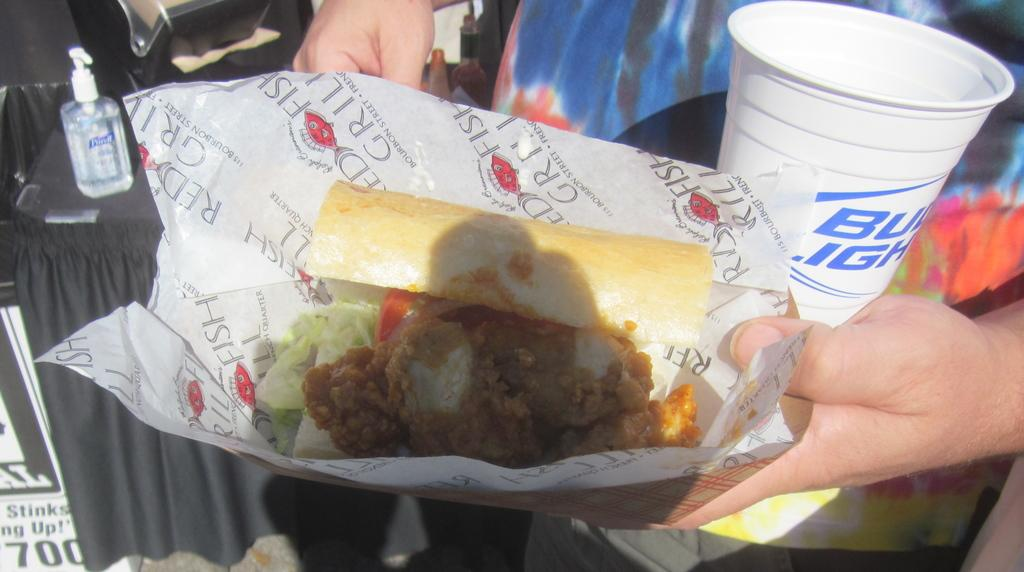What is the person in the image doing? The person is standing and holding a cup and cover with food. What else can be seen on the table in the image? There is a bottle on the table in the image. What is the board used for in the image? The purpose of the board in the image is not specified, but it is present. Can you describe the objects visible in the image? Yes, there are objects visible in the image, including the person, the cup and cover with food, the bottle, and the board. Why is the person in the image crying? There is no indication in the image that the person is crying. 